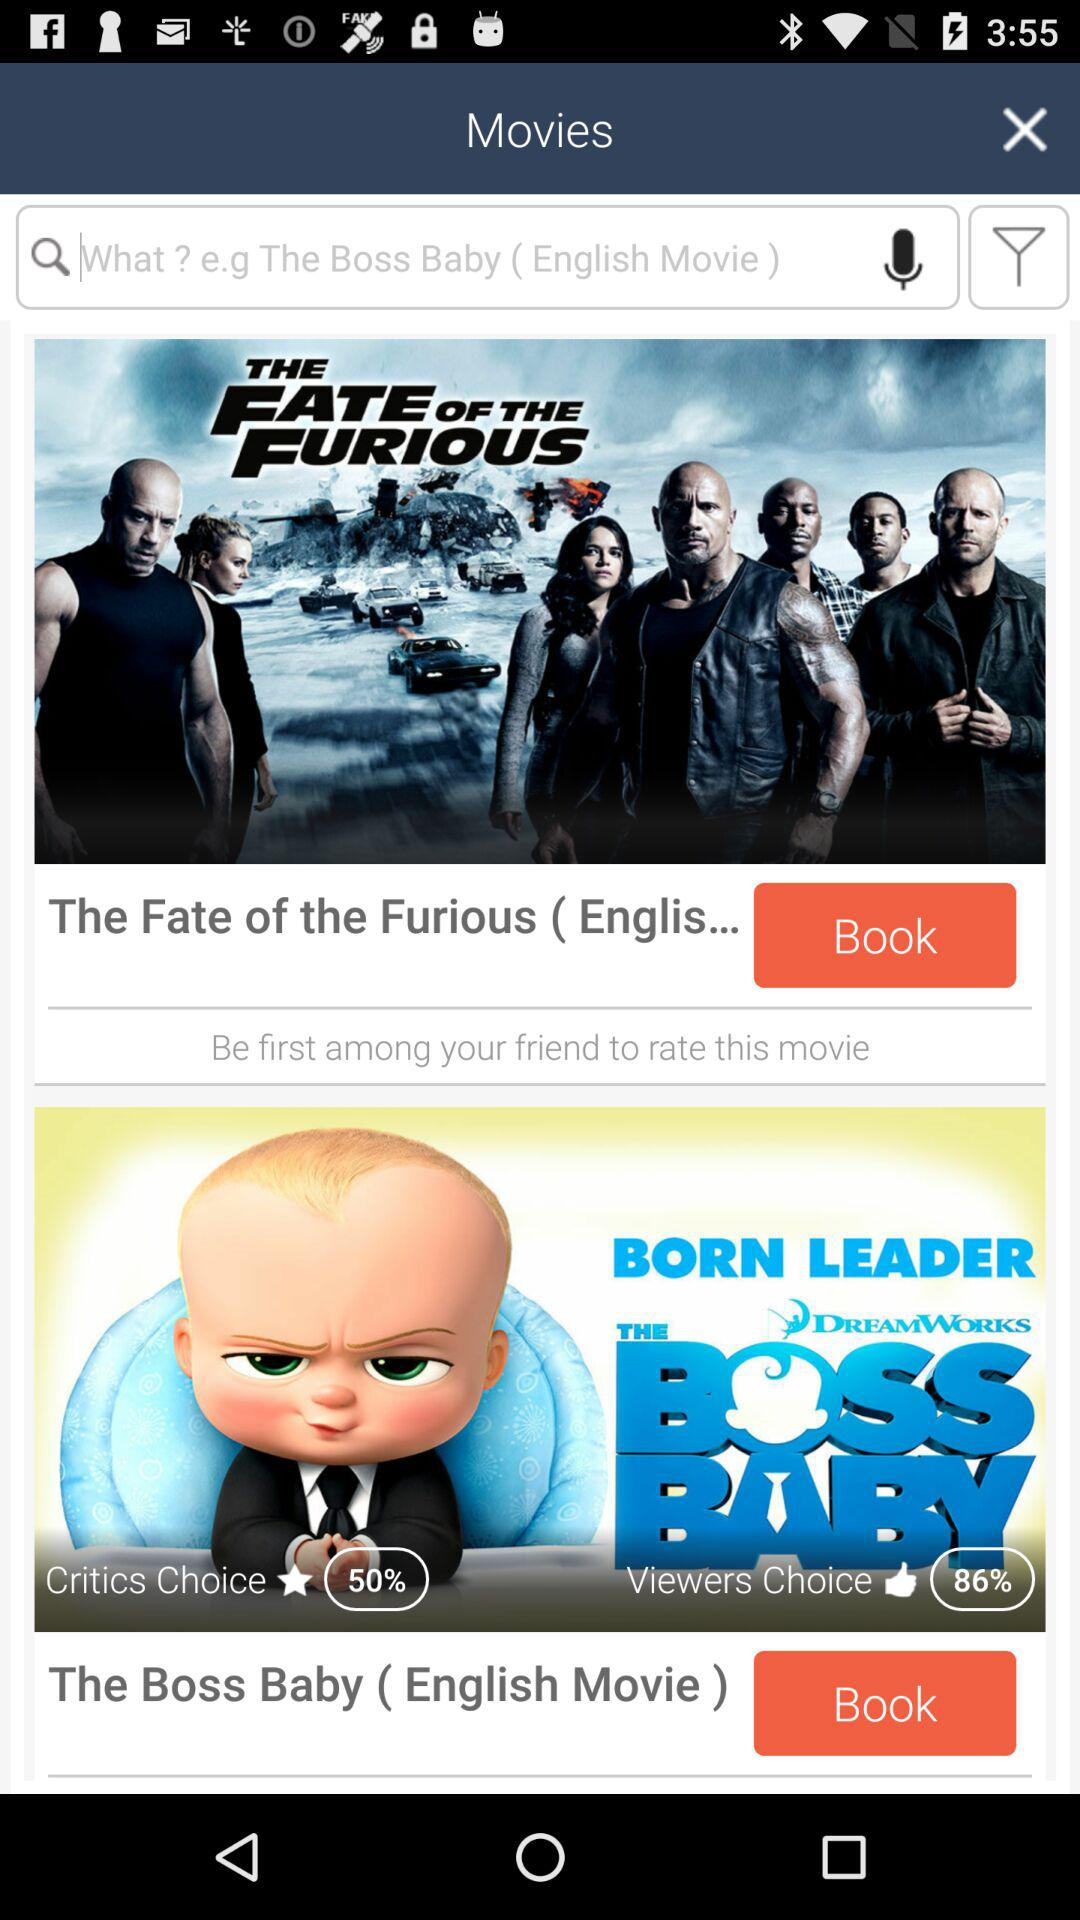Which movie has the higher critic rating, The Fate of the Furious or The Boss Baby?
Answer the question using a single word or phrase. The Boss Baby 